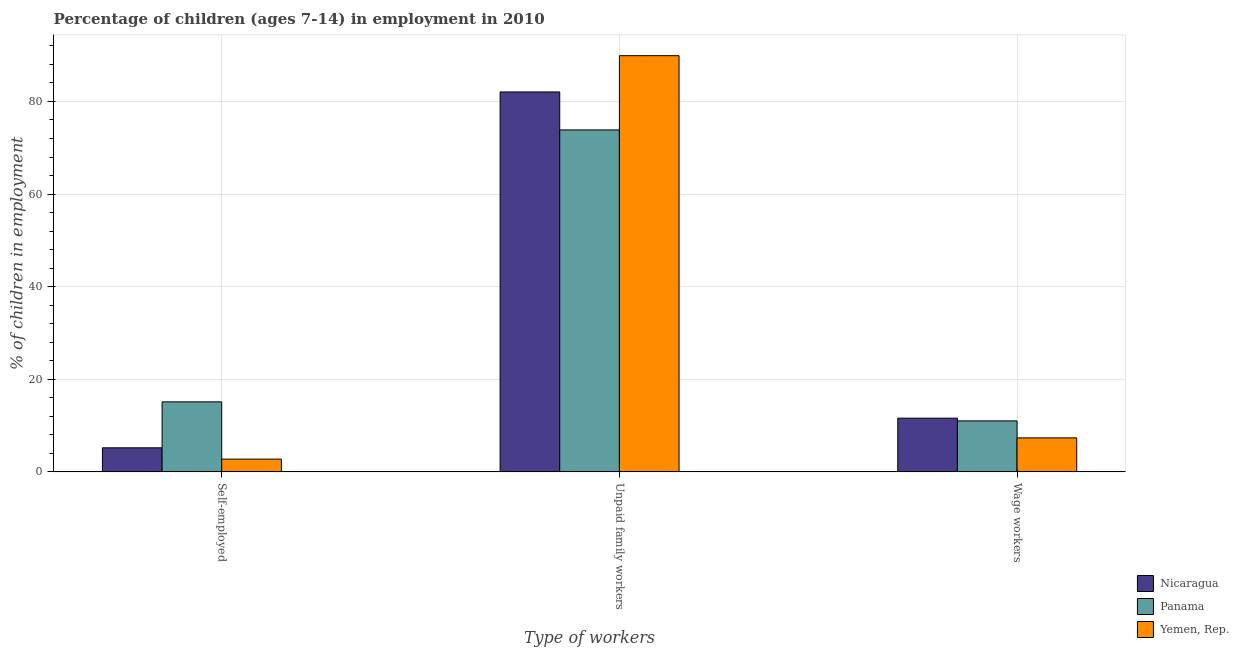How many different coloured bars are there?
Offer a very short reply. 3. Are the number of bars on each tick of the X-axis equal?
Your answer should be compact. Yes. How many bars are there on the 3rd tick from the right?
Provide a succinct answer. 3. What is the label of the 3rd group of bars from the left?
Ensure brevity in your answer.  Wage workers. What is the percentage of self employed children in Panama?
Offer a terse response. 15.13. Across all countries, what is the maximum percentage of children employed as wage workers?
Provide a succinct answer. 11.61. Across all countries, what is the minimum percentage of children employed as wage workers?
Offer a terse response. 7.35. In which country was the percentage of self employed children maximum?
Ensure brevity in your answer.  Panama. In which country was the percentage of self employed children minimum?
Ensure brevity in your answer.  Yemen, Rep. What is the total percentage of children employed as wage workers in the graph?
Give a very brief answer. 29.98. What is the difference between the percentage of children employed as wage workers in Panama and that in Nicaragua?
Your answer should be very brief. -0.59. What is the difference between the percentage of self employed children in Nicaragua and the percentage of children employed as wage workers in Panama?
Ensure brevity in your answer.  -5.81. What is the average percentage of self employed children per country?
Your response must be concise. 7.7. What is the difference between the percentage of self employed children and percentage of children employed as wage workers in Yemen, Rep.?
Your answer should be compact. -4.58. In how many countries, is the percentage of children employed as wage workers greater than 24 %?
Ensure brevity in your answer.  0. What is the ratio of the percentage of children employed as wage workers in Yemen, Rep. to that in Nicaragua?
Give a very brief answer. 0.63. What is the difference between the highest and the second highest percentage of children employed as wage workers?
Provide a short and direct response. 0.59. What is the difference between the highest and the lowest percentage of children employed as wage workers?
Offer a terse response. 4.26. In how many countries, is the percentage of children employed as wage workers greater than the average percentage of children employed as wage workers taken over all countries?
Offer a very short reply. 2. Is the sum of the percentage of self employed children in Nicaragua and Yemen, Rep. greater than the maximum percentage of children employed as unpaid family workers across all countries?
Make the answer very short. No. What does the 3rd bar from the left in Wage workers represents?
Your response must be concise. Yemen, Rep. What does the 3rd bar from the right in Wage workers represents?
Make the answer very short. Nicaragua. Is it the case that in every country, the sum of the percentage of self employed children and percentage of children employed as unpaid family workers is greater than the percentage of children employed as wage workers?
Your answer should be compact. Yes. How many bars are there?
Make the answer very short. 9. What is the difference between two consecutive major ticks on the Y-axis?
Give a very brief answer. 20. Does the graph contain any zero values?
Provide a succinct answer. No. Where does the legend appear in the graph?
Give a very brief answer. Bottom right. How many legend labels are there?
Offer a very short reply. 3. How are the legend labels stacked?
Ensure brevity in your answer.  Vertical. What is the title of the graph?
Your answer should be compact. Percentage of children (ages 7-14) in employment in 2010. Does "Paraguay" appear as one of the legend labels in the graph?
Make the answer very short. No. What is the label or title of the X-axis?
Ensure brevity in your answer.  Type of workers. What is the label or title of the Y-axis?
Make the answer very short. % of children in employment. What is the % of children in employment in Nicaragua in Self-employed?
Your answer should be compact. 5.21. What is the % of children in employment of Panama in Self-employed?
Your response must be concise. 15.13. What is the % of children in employment of Yemen, Rep. in Self-employed?
Your response must be concise. 2.77. What is the % of children in employment of Nicaragua in Unpaid family workers?
Offer a terse response. 82.05. What is the % of children in employment of Panama in Unpaid family workers?
Give a very brief answer. 73.85. What is the % of children in employment in Yemen, Rep. in Unpaid family workers?
Provide a succinct answer. 89.88. What is the % of children in employment in Nicaragua in Wage workers?
Your response must be concise. 11.61. What is the % of children in employment in Panama in Wage workers?
Provide a short and direct response. 11.02. What is the % of children in employment of Yemen, Rep. in Wage workers?
Your answer should be compact. 7.35. Across all Type of workers, what is the maximum % of children in employment of Nicaragua?
Offer a terse response. 82.05. Across all Type of workers, what is the maximum % of children in employment of Panama?
Your answer should be compact. 73.85. Across all Type of workers, what is the maximum % of children in employment in Yemen, Rep.?
Offer a terse response. 89.88. Across all Type of workers, what is the minimum % of children in employment in Nicaragua?
Provide a short and direct response. 5.21. Across all Type of workers, what is the minimum % of children in employment of Panama?
Provide a short and direct response. 11.02. Across all Type of workers, what is the minimum % of children in employment in Yemen, Rep.?
Make the answer very short. 2.77. What is the total % of children in employment in Nicaragua in the graph?
Offer a very short reply. 98.87. What is the total % of children in employment in Panama in the graph?
Offer a terse response. 100. What is the total % of children in employment of Yemen, Rep. in the graph?
Ensure brevity in your answer.  100. What is the difference between the % of children in employment of Nicaragua in Self-employed and that in Unpaid family workers?
Offer a very short reply. -76.84. What is the difference between the % of children in employment in Panama in Self-employed and that in Unpaid family workers?
Your answer should be compact. -58.72. What is the difference between the % of children in employment in Yemen, Rep. in Self-employed and that in Unpaid family workers?
Your answer should be compact. -87.11. What is the difference between the % of children in employment of Nicaragua in Self-employed and that in Wage workers?
Offer a very short reply. -6.4. What is the difference between the % of children in employment in Panama in Self-employed and that in Wage workers?
Your response must be concise. 4.11. What is the difference between the % of children in employment in Yemen, Rep. in Self-employed and that in Wage workers?
Your answer should be compact. -4.58. What is the difference between the % of children in employment in Nicaragua in Unpaid family workers and that in Wage workers?
Provide a short and direct response. 70.44. What is the difference between the % of children in employment in Panama in Unpaid family workers and that in Wage workers?
Give a very brief answer. 62.83. What is the difference between the % of children in employment of Yemen, Rep. in Unpaid family workers and that in Wage workers?
Ensure brevity in your answer.  82.53. What is the difference between the % of children in employment of Nicaragua in Self-employed and the % of children in employment of Panama in Unpaid family workers?
Offer a terse response. -68.64. What is the difference between the % of children in employment of Nicaragua in Self-employed and the % of children in employment of Yemen, Rep. in Unpaid family workers?
Make the answer very short. -84.67. What is the difference between the % of children in employment in Panama in Self-employed and the % of children in employment in Yemen, Rep. in Unpaid family workers?
Make the answer very short. -74.75. What is the difference between the % of children in employment of Nicaragua in Self-employed and the % of children in employment of Panama in Wage workers?
Provide a short and direct response. -5.81. What is the difference between the % of children in employment of Nicaragua in Self-employed and the % of children in employment of Yemen, Rep. in Wage workers?
Offer a terse response. -2.14. What is the difference between the % of children in employment in Panama in Self-employed and the % of children in employment in Yemen, Rep. in Wage workers?
Provide a succinct answer. 7.78. What is the difference between the % of children in employment in Nicaragua in Unpaid family workers and the % of children in employment in Panama in Wage workers?
Offer a terse response. 71.03. What is the difference between the % of children in employment of Nicaragua in Unpaid family workers and the % of children in employment of Yemen, Rep. in Wage workers?
Keep it short and to the point. 74.7. What is the difference between the % of children in employment of Panama in Unpaid family workers and the % of children in employment of Yemen, Rep. in Wage workers?
Provide a short and direct response. 66.5. What is the average % of children in employment of Nicaragua per Type of workers?
Give a very brief answer. 32.96. What is the average % of children in employment in Panama per Type of workers?
Your answer should be compact. 33.33. What is the average % of children in employment in Yemen, Rep. per Type of workers?
Ensure brevity in your answer.  33.33. What is the difference between the % of children in employment of Nicaragua and % of children in employment of Panama in Self-employed?
Ensure brevity in your answer.  -9.92. What is the difference between the % of children in employment in Nicaragua and % of children in employment in Yemen, Rep. in Self-employed?
Your response must be concise. 2.44. What is the difference between the % of children in employment in Panama and % of children in employment in Yemen, Rep. in Self-employed?
Give a very brief answer. 12.36. What is the difference between the % of children in employment of Nicaragua and % of children in employment of Yemen, Rep. in Unpaid family workers?
Offer a terse response. -7.83. What is the difference between the % of children in employment in Panama and % of children in employment in Yemen, Rep. in Unpaid family workers?
Offer a terse response. -16.03. What is the difference between the % of children in employment in Nicaragua and % of children in employment in Panama in Wage workers?
Your answer should be very brief. 0.59. What is the difference between the % of children in employment in Nicaragua and % of children in employment in Yemen, Rep. in Wage workers?
Offer a terse response. 4.26. What is the difference between the % of children in employment of Panama and % of children in employment of Yemen, Rep. in Wage workers?
Make the answer very short. 3.67. What is the ratio of the % of children in employment of Nicaragua in Self-employed to that in Unpaid family workers?
Give a very brief answer. 0.06. What is the ratio of the % of children in employment of Panama in Self-employed to that in Unpaid family workers?
Ensure brevity in your answer.  0.2. What is the ratio of the % of children in employment of Yemen, Rep. in Self-employed to that in Unpaid family workers?
Keep it short and to the point. 0.03. What is the ratio of the % of children in employment of Nicaragua in Self-employed to that in Wage workers?
Offer a very short reply. 0.45. What is the ratio of the % of children in employment in Panama in Self-employed to that in Wage workers?
Ensure brevity in your answer.  1.37. What is the ratio of the % of children in employment of Yemen, Rep. in Self-employed to that in Wage workers?
Your answer should be compact. 0.38. What is the ratio of the % of children in employment of Nicaragua in Unpaid family workers to that in Wage workers?
Your answer should be very brief. 7.07. What is the ratio of the % of children in employment in Panama in Unpaid family workers to that in Wage workers?
Offer a very short reply. 6.7. What is the ratio of the % of children in employment in Yemen, Rep. in Unpaid family workers to that in Wage workers?
Your answer should be compact. 12.23. What is the difference between the highest and the second highest % of children in employment in Nicaragua?
Keep it short and to the point. 70.44. What is the difference between the highest and the second highest % of children in employment of Panama?
Give a very brief answer. 58.72. What is the difference between the highest and the second highest % of children in employment in Yemen, Rep.?
Make the answer very short. 82.53. What is the difference between the highest and the lowest % of children in employment in Nicaragua?
Provide a succinct answer. 76.84. What is the difference between the highest and the lowest % of children in employment in Panama?
Keep it short and to the point. 62.83. What is the difference between the highest and the lowest % of children in employment of Yemen, Rep.?
Your answer should be compact. 87.11. 